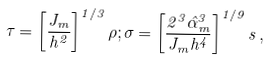Convert formula to latex. <formula><loc_0><loc_0><loc_500><loc_500>\tau = \left [ \frac { J _ { m } } { h ^ { 2 } } \right ] ^ { 1 / 3 } \rho ; \sigma = \left [ \frac { 2 ^ { 3 } \hat { \alpha } _ { m } ^ { 3 } } { J _ { m } h ^ { 4 } } \right ] ^ { 1 / 9 } s \, ,</formula> 